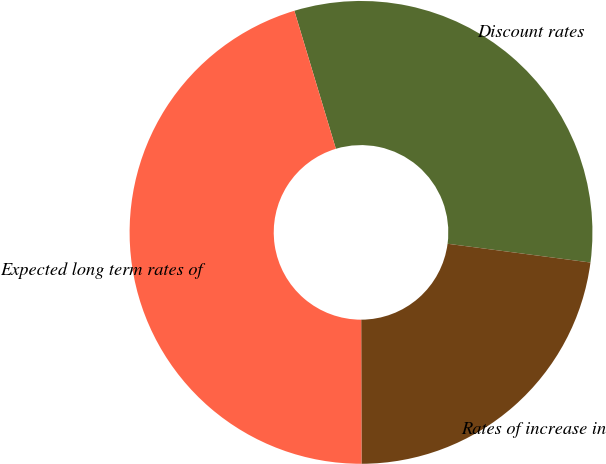Convert chart to OTSL. <chart><loc_0><loc_0><loc_500><loc_500><pie_chart><fcel>Discount rates<fcel>Rates of increase in<fcel>Expected long term rates of<nl><fcel>31.73%<fcel>22.89%<fcel>45.38%<nl></chart> 